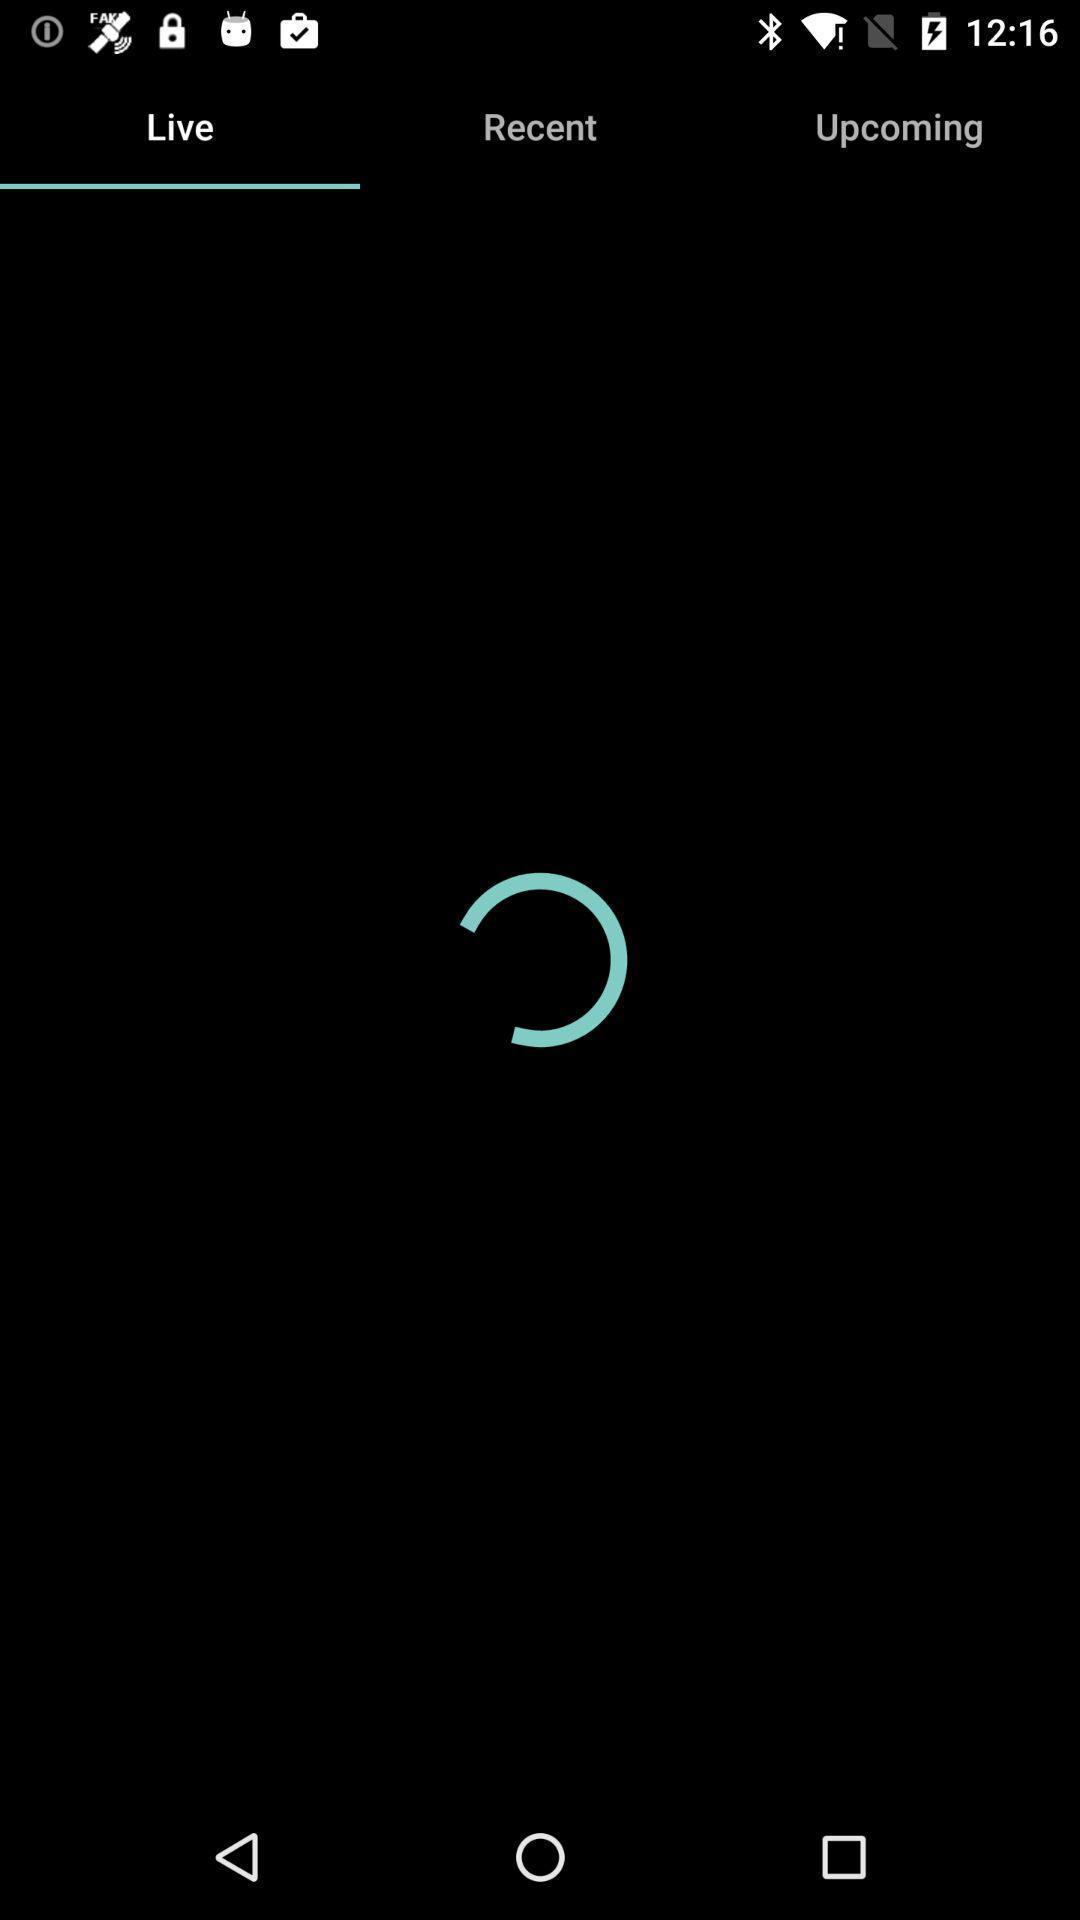Describe the key features of this screenshot. Screen shows live details in a sports application. 